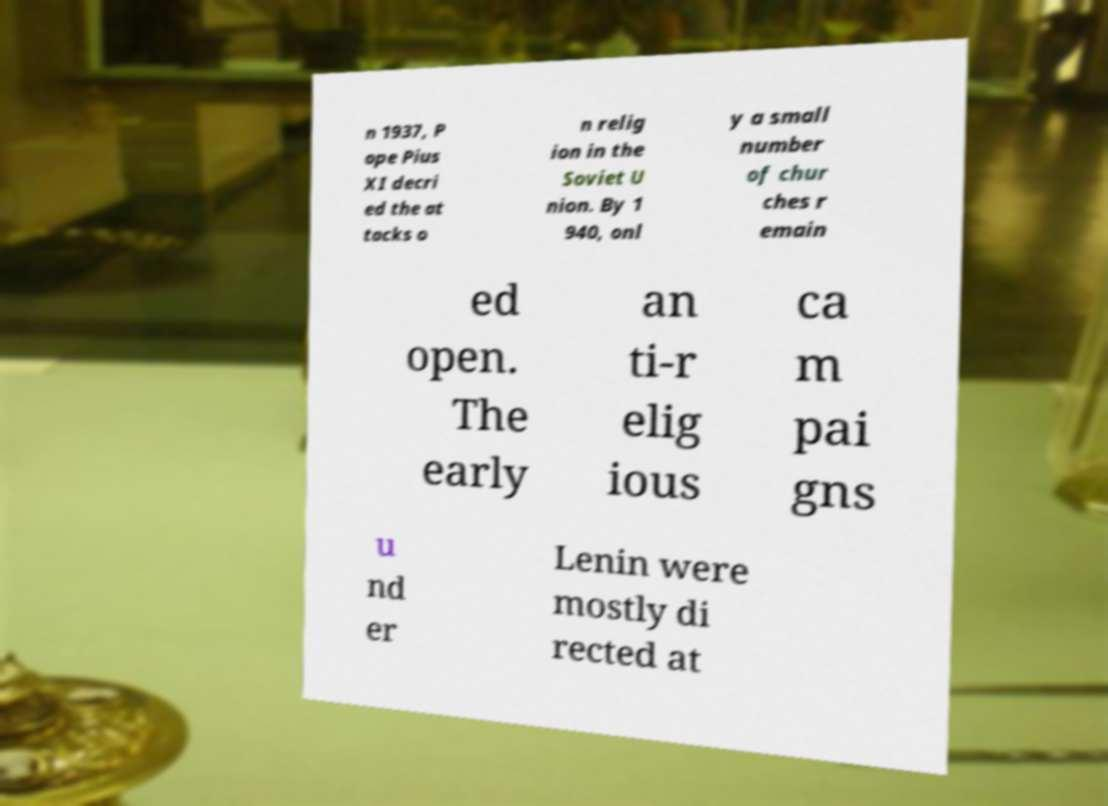Could you extract and type out the text from this image? n 1937, P ope Pius XI decri ed the at tacks o n relig ion in the Soviet U nion. By 1 940, onl y a small number of chur ches r emain ed open. The early an ti-r elig ious ca m pai gns u nd er Lenin were mostly di rected at 